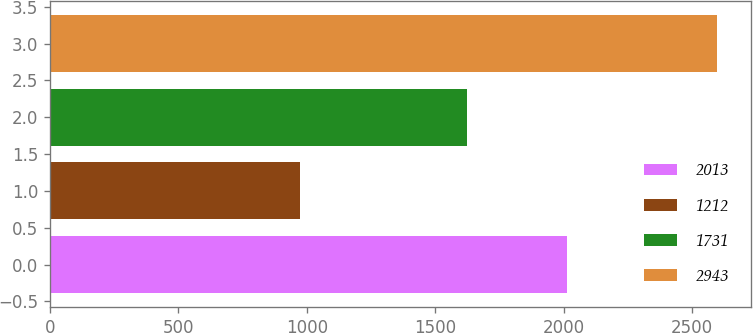Convert chart. <chart><loc_0><loc_0><loc_500><loc_500><bar_chart><fcel>2013<fcel>1212<fcel>1731<fcel>2943<nl><fcel>2011<fcel>975<fcel>1622<fcel>2597<nl></chart> 